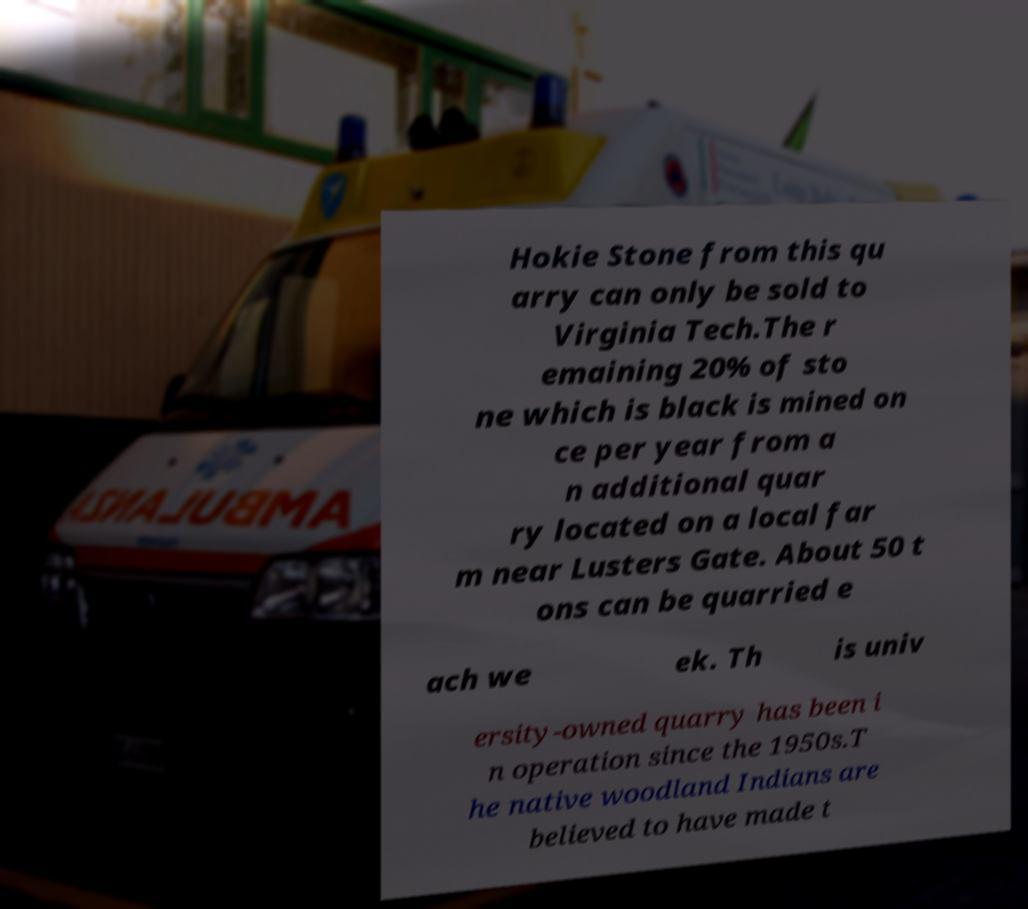Could you extract and type out the text from this image? Hokie Stone from this qu arry can only be sold to Virginia Tech.The r emaining 20% of sto ne which is black is mined on ce per year from a n additional quar ry located on a local far m near Lusters Gate. About 50 t ons can be quarried e ach we ek. Th is univ ersity-owned quarry has been i n operation since the 1950s.T he native woodland Indians are believed to have made t 